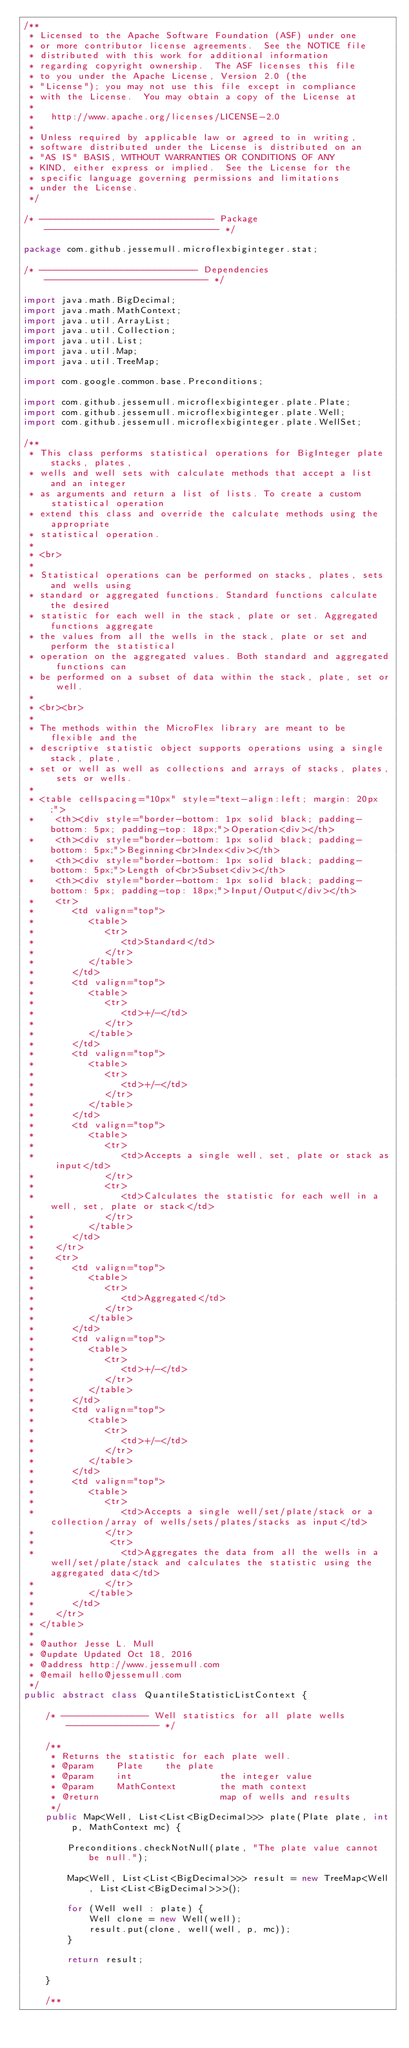Convert code to text. <code><loc_0><loc_0><loc_500><loc_500><_Java_>/**
 * Licensed to the Apache Software Foundation (ASF) under one
 * or more contributor license agreements.  See the NOTICE file
 * distributed with this work for additional information
 * regarding copyright ownership.  The ASF licenses this file
 * to you under the Apache License, Version 2.0 (the
 * "License"); you may not use this file except in compliance
 * with the License.  You may obtain a copy of the License at
 *
 *   http://www.apache.org/licenses/LICENSE-2.0
 *
 * Unless required by applicable law or agreed to in writing,
 * software distributed under the License is distributed on an
 * "AS IS" BASIS, WITHOUT WARRANTIES OR CONDITIONS OF ANY
 * KIND, either express or implied.  See the License for the
 * specific language governing permissions and limitations
 * under the License.
 */

/* -------------------------------- Package -------------------------------- */

package com.github.jessemull.microflexbiginteger.stat;

/* ----------------------------- Dependencies ------------------------------ */

import java.math.BigDecimal;
import java.math.MathContext;
import java.util.ArrayList;
import java.util.Collection;
import java.util.List;
import java.util.Map;
import java.util.TreeMap;

import com.google.common.base.Preconditions;

import com.github.jessemull.microflexbiginteger.plate.Plate;
import com.github.jessemull.microflexbiginteger.plate.Well;
import com.github.jessemull.microflexbiginteger.plate.WellSet;

/**
 * This class performs statistical operations for BigInteger plate stacks, plates, 
 * wells and well sets with calculate methods that accept a list and an integer
 * as arguments and return a list of lists. To create a custom statistical operation 
 * extend this class and override the calculate methods using the appropriate 
 * statistical operation. 
 * 
 * <br>
 * 
 * Statistical operations can be performed on stacks, plates, sets and wells using
 * standard or aggregated functions. Standard functions calculate the desired
 * statistic for each well in the stack, plate or set. Aggregated functions aggregate
 * the values from all the wells in the stack, plate or set and perform the statistical
 * operation on the aggregated values. Both standard and aggregated functions can
 * be performed on a subset of data within the stack, plate, set or well.
 * 
 * <br><br>
 * 
 * The methods within the MicroFlex library are meant to be flexible and the
 * descriptive statistic object supports operations using a single stack, plate,
 * set or well as well as collections and arrays of stacks, plates, sets or wells. 
 *  
 * <table cellspacing="10px" style="text-align:left; margin: 20px;">
 *    <th><div style="border-bottom: 1px solid black; padding-bottom: 5px; padding-top: 18px;">Operation<div></th>
 *    <th><div style="border-bottom: 1px solid black; padding-bottom: 5px;">Beginning<br>Index<div></th>
 *    <th><div style="border-bottom: 1px solid black; padding-bottom: 5px;">Length of<br>Subset<div></th>
 *    <th><div style="border-bottom: 1px solid black; padding-bottom: 5px; padding-top: 18px;">Input/Output</div></th>
 *    <tr>
 *       <td valign="top">
 *          <table>
 *             <tr>
 *                <td>Standard</td>
 *             </tr>
 *          </table>  
 *       </td>
 *       <td valign="top">
 *          <table>
 *             <tr>
 *                <td>+/-</td>
 *             </tr>
 *          </table>  
 *       </td>
 *       <td valign="top">
 *          <table>
 *             <tr>
 *                <td>+/-</td>
 *             </tr>
 *          </table>  
 *       </td>
 *       <td valign="top">
 *          <table>
 *             <tr>
 *                <td>Accepts a single well, set, plate or stack as input</td>
 *             </tr>
 *             <tr>
 *                <td>Calculates the statistic for each well in a well, set, plate or stack</td>
 *             </tr>
 *          </table>  
 *       </td>
 *    </tr>
 *    <tr>
 *       <td valign="top">
 *          <table>
 *             <tr>
 *                <td>Aggregated</td>
 *             </tr>
 *          </table>  
 *       </td>
 *       <td valign="top">
 *          <table>
 *             <tr>
 *                <td>+/-</td>
 *             </tr>
 *          </table>  
 *       </td>
 *       <td valign="top">
 *          <table>
 *             <tr>
 *                <td>+/-</td>
 *             </tr>
 *          </table>  
 *       </td>
 *       <td valign="top">
 *          <table>
 *             <tr>
 *                <td>Accepts a single well/set/plate/stack or a collection/array of wells/sets/plates/stacks as input</td>
 *             </tr>
 *              <tr>
 *                <td>Aggregates the data from all the wells in a well/set/plate/stack and calculates the statistic using the aggregated data</td>
 *             </tr>
 *          </table>  
 *       </td>
 *    </tr>
 * </table>
 * 
 * @author Jesse L. Mull
 * @update Updated Oct 18, 2016
 * @address http://www.jessemull.com
 * @email hello@jessemull.com
 */
public abstract class QuantileStatisticListContext {
    
    /* ---------------- Well statistics for all plate wells ----------------- */
    
    /**
     * Returns the statistic for each plate well.
     * @param    Plate    the plate
     * @param    int                the integer value
     * @param    MathContext        the math context
     * @return                      map of wells and results
     */
    public Map<Well, List<List<BigDecimal>>> plate(Plate plate, int p, MathContext mc) {
        
        Preconditions.checkNotNull(plate, "The plate value cannot be null.");
        
        Map<Well, List<List<BigDecimal>>> result = new TreeMap<Well, List<List<BigDecimal>>>();
        
        for (Well well : plate) {
            Well clone = new Well(well);
            result.put(clone, well(well, p, mc));
        }
      
        return result;
        
    }
    
    /**</code> 